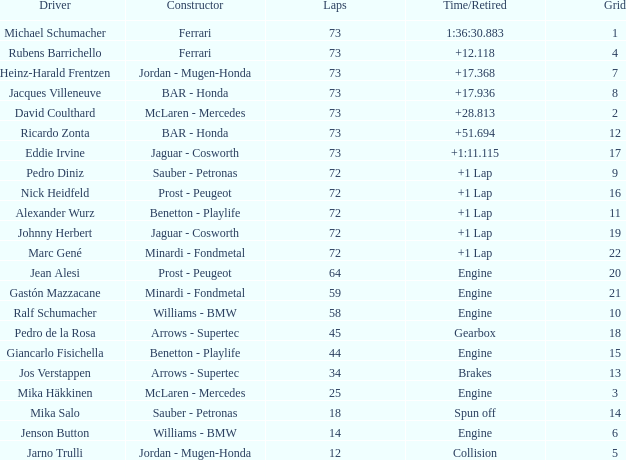How many laps did giancarlo fisichella perform with a grid greater than 15? 0.0. 